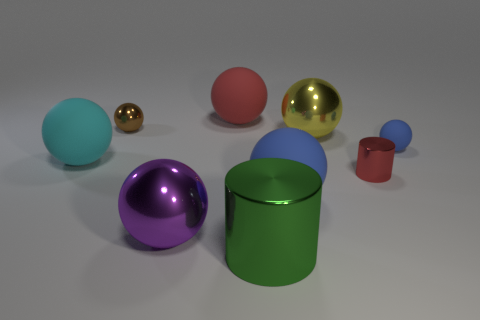There is a matte thing that is the same color as the small cylinder; what is its shape?
Your response must be concise. Sphere. What is the shape of the tiny red object?
Keep it short and to the point. Cylinder. What number of blue matte cubes are the same size as the yellow object?
Ensure brevity in your answer.  0. Is the big red thing the same shape as the large cyan object?
Provide a short and direct response. Yes. What color is the tiny shiny object in front of the rubber object that is on the left side of the large purple sphere?
Offer a very short reply. Red. There is a sphere that is right of the big green metal cylinder and on the left side of the yellow metal thing; what size is it?
Your answer should be very brief. Large. Is there any other thing that is the same color as the big cylinder?
Offer a very short reply. No. There is a large red thing that is made of the same material as the small blue sphere; what is its shape?
Provide a short and direct response. Sphere. There is a brown object; does it have the same shape as the tiny shiny object that is in front of the brown ball?
Provide a short and direct response. No. What is the material of the tiny sphere to the left of the cylinder in front of the purple sphere?
Ensure brevity in your answer.  Metal. 